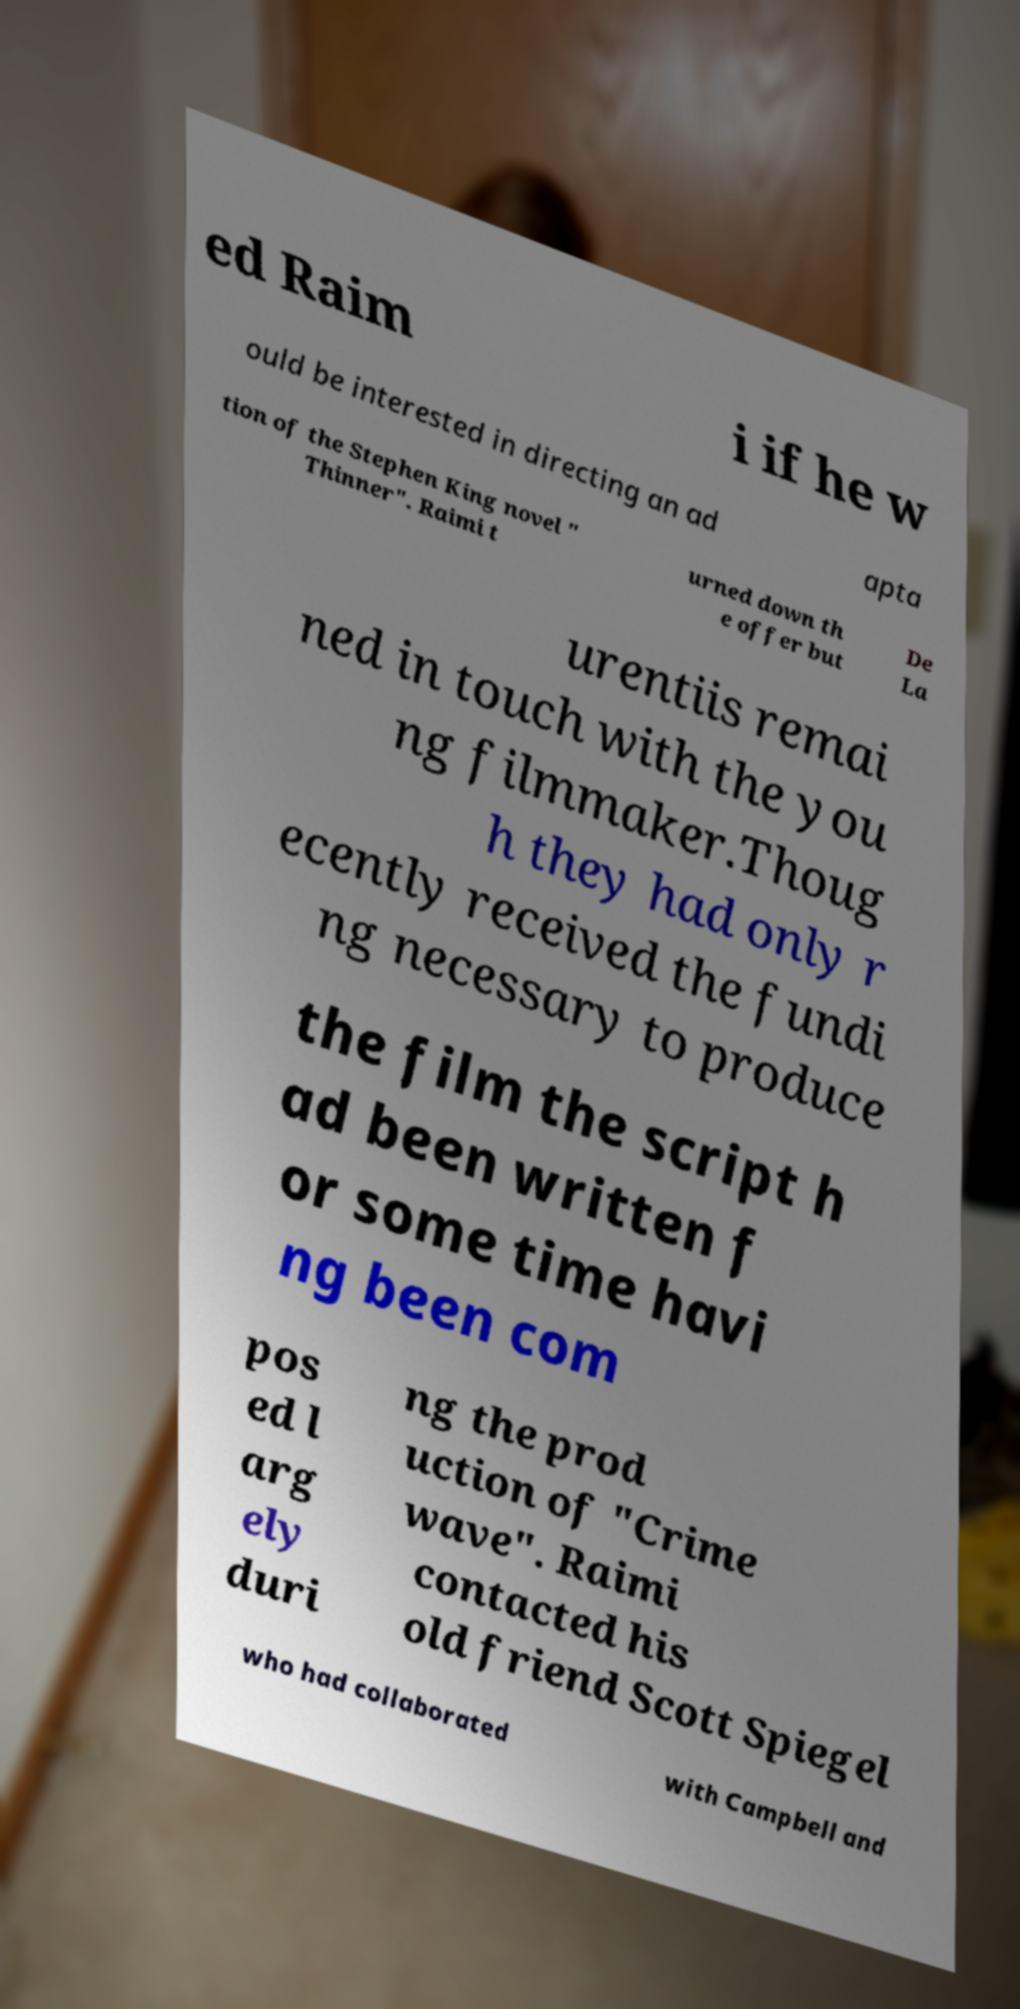What messages or text are displayed in this image? I need them in a readable, typed format. ed Raim i if he w ould be interested in directing an ad apta tion of the Stephen King novel " Thinner". Raimi t urned down th e offer but De La urentiis remai ned in touch with the you ng filmmaker.Thoug h they had only r ecently received the fundi ng necessary to produce the film the script h ad been written f or some time havi ng been com pos ed l arg ely duri ng the prod uction of "Crime wave". Raimi contacted his old friend Scott Spiegel who had collaborated with Campbell and 